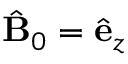<formula> <loc_0><loc_0><loc_500><loc_500>\hat { B } _ { 0 } = \hat { e } _ { z }</formula> 